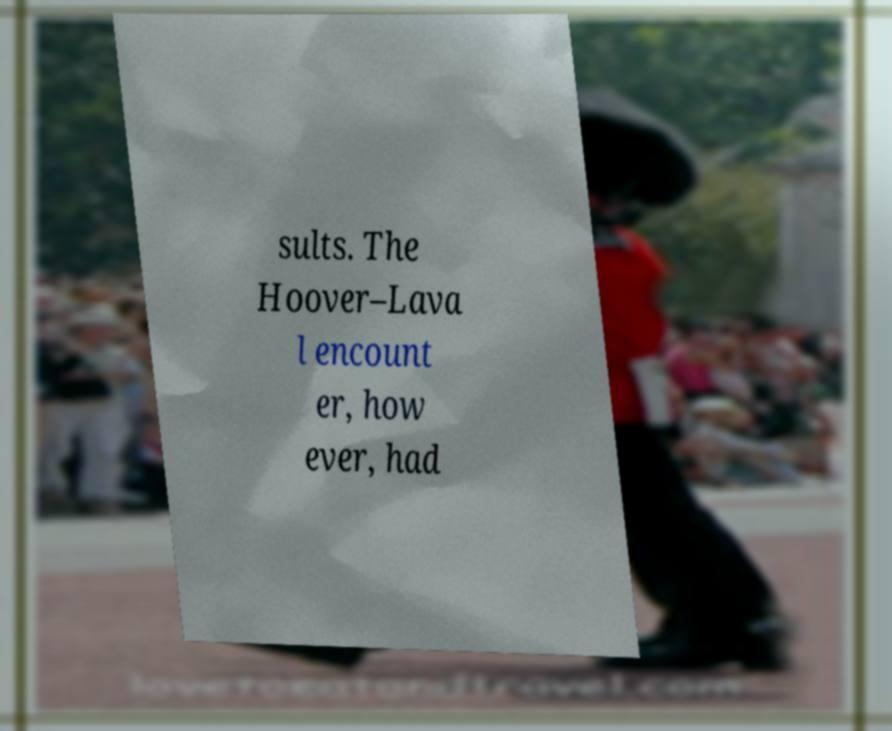There's text embedded in this image that I need extracted. Can you transcribe it verbatim? sults. The Hoover–Lava l encount er, how ever, had 